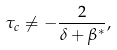<formula> <loc_0><loc_0><loc_500><loc_500>\tau _ { c } \neq - \frac { 2 } { \delta + \beta ^ { * } } ,</formula> 